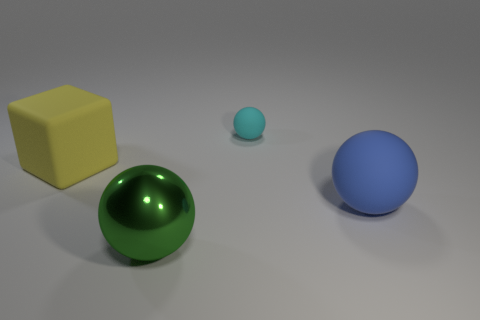There is a matte object in front of the yellow block; how big is it?
Offer a very short reply. Large. How big is the rubber thing left of the rubber ball behind the blue thing?
Make the answer very short. Large. There is a yellow cube that is the same size as the green sphere; what is it made of?
Your answer should be compact. Rubber. There is a large yellow matte object; are there any green things behind it?
Make the answer very short. No. Is the number of green metal objects behind the big yellow rubber object the same as the number of yellow matte blocks?
Provide a succinct answer. No. There is a matte object that is the same size as the yellow rubber block; what shape is it?
Provide a succinct answer. Sphere. What material is the big yellow thing?
Your response must be concise. Rubber. There is a object that is both behind the large shiny sphere and in front of the yellow rubber block; what is its color?
Keep it short and to the point. Blue. Are there the same number of big blue things that are in front of the big green metal ball and blocks that are on the right side of the cyan ball?
Provide a short and direct response. Yes. What color is the big block that is made of the same material as the cyan object?
Make the answer very short. Yellow. 